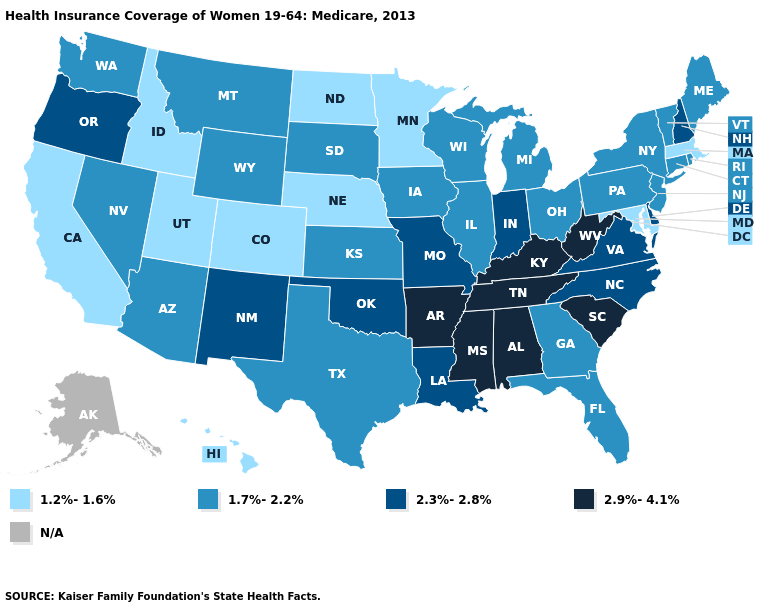Does Massachusetts have the lowest value in the Northeast?
Write a very short answer. Yes. Among the states that border Vermont , which have the highest value?
Keep it brief. New Hampshire. Among the states that border Georgia , which have the highest value?
Give a very brief answer. Alabama, South Carolina, Tennessee. What is the value of Wisconsin?
Give a very brief answer. 1.7%-2.2%. Name the states that have a value in the range 2.3%-2.8%?
Write a very short answer. Delaware, Indiana, Louisiana, Missouri, New Hampshire, New Mexico, North Carolina, Oklahoma, Oregon, Virginia. Does Vermont have the highest value in the USA?
Quick response, please. No. Which states have the lowest value in the West?
Concise answer only. California, Colorado, Hawaii, Idaho, Utah. Among the states that border Nevada , which have the highest value?
Quick response, please. Oregon. What is the value of California?
Short answer required. 1.2%-1.6%. Name the states that have a value in the range 2.3%-2.8%?
Answer briefly. Delaware, Indiana, Louisiana, Missouri, New Hampshire, New Mexico, North Carolina, Oklahoma, Oregon, Virginia. Does the map have missing data?
Answer briefly. Yes. Is the legend a continuous bar?
Give a very brief answer. No. Among the states that border Rhode Island , does Connecticut have the lowest value?
Quick response, please. No. Name the states that have a value in the range 1.2%-1.6%?
Be succinct. California, Colorado, Hawaii, Idaho, Maryland, Massachusetts, Minnesota, Nebraska, North Dakota, Utah. 